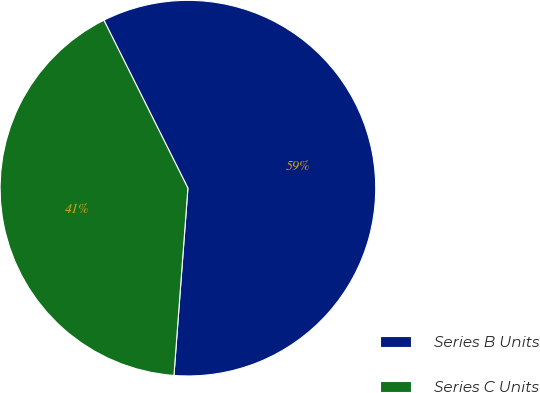<chart> <loc_0><loc_0><loc_500><loc_500><pie_chart><fcel>Series B Units<fcel>Series C Units<nl><fcel>58.57%<fcel>41.43%<nl></chart> 